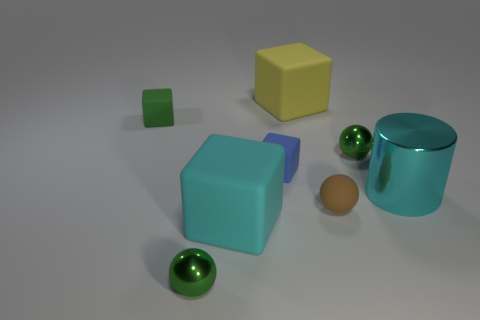What shape is the small green metal object that is on the left side of the large yellow rubber object? The small green metal object positioned to the left of the large yellow rubber object is a cube. Its distinct edges and flat faces are characteristic of a cubic shape. 